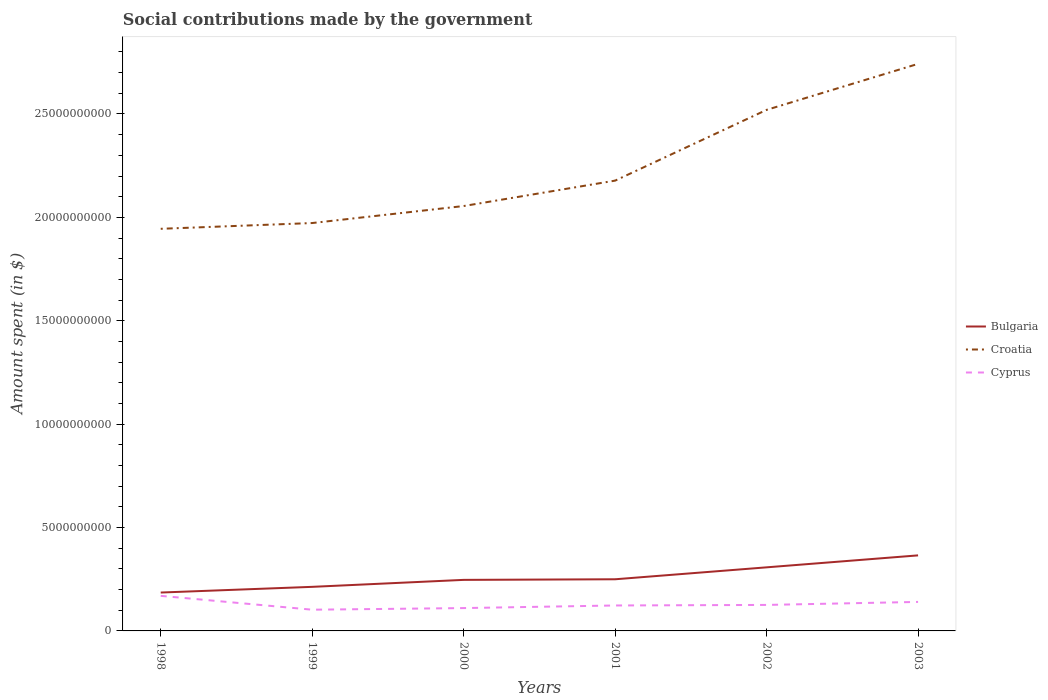How many different coloured lines are there?
Offer a very short reply. 3. Does the line corresponding to Bulgaria intersect with the line corresponding to Cyprus?
Your response must be concise. No. Across all years, what is the maximum amount spent on social contributions in Cyprus?
Offer a very short reply. 1.03e+09. What is the total amount spent on social contributions in Croatia in the graph?
Offer a very short reply. -3.42e+09. What is the difference between the highest and the second highest amount spent on social contributions in Croatia?
Give a very brief answer. 7.98e+09. What is the difference between the highest and the lowest amount spent on social contributions in Cyprus?
Your response must be concise. 2. What is the difference between two consecutive major ticks on the Y-axis?
Offer a terse response. 5.00e+09. Are the values on the major ticks of Y-axis written in scientific E-notation?
Provide a succinct answer. No. How many legend labels are there?
Provide a short and direct response. 3. What is the title of the graph?
Your response must be concise. Social contributions made by the government. Does "Uganda" appear as one of the legend labels in the graph?
Offer a terse response. No. What is the label or title of the X-axis?
Offer a terse response. Years. What is the label or title of the Y-axis?
Offer a very short reply. Amount spent (in $). What is the Amount spent (in $) of Bulgaria in 1998?
Offer a terse response. 1.86e+09. What is the Amount spent (in $) of Croatia in 1998?
Provide a succinct answer. 1.94e+1. What is the Amount spent (in $) in Cyprus in 1998?
Provide a succinct answer. 1.70e+09. What is the Amount spent (in $) in Bulgaria in 1999?
Offer a very short reply. 2.13e+09. What is the Amount spent (in $) of Croatia in 1999?
Give a very brief answer. 1.97e+1. What is the Amount spent (in $) in Cyprus in 1999?
Make the answer very short. 1.03e+09. What is the Amount spent (in $) in Bulgaria in 2000?
Your answer should be compact. 2.47e+09. What is the Amount spent (in $) in Croatia in 2000?
Offer a terse response. 2.05e+1. What is the Amount spent (in $) in Cyprus in 2000?
Your response must be concise. 1.10e+09. What is the Amount spent (in $) in Bulgaria in 2001?
Offer a very short reply. 2.50e+09. What is the Amount spent (in $) of Croatia in 2001?
Give a very brief answer. 2.18e+1. What is the Amount spent (in $) in Cyprus in 2001?
Make the answer very short. 1.23e+09. What is the Amount spent (in $) in Bulgaria in 2002?
Provide a short and direct response. 3.08e+09. What is the Amount spent (in $) in Croatia in 2002?
Give a very brief answer. 2.52e+1. What is the Amount spent (in $) in Cyprus in 2002?
Make the answer very short. 1.26e+09. What is the Amount spent (in $) of Bulgaria in 2003?
Your answer should be compact. 3.65e+09. What is the Amount spent (in $) of Croatia in 2003?
Make the answer very short. 2.74e+1. What is the Amount spent (in $) of Cyprus in 2003?
Ensure brevity in your answer.  1.40e+09. Across all years, what is the maximum Amount spent (in $) in Bulgaria?
Provide a succinct answer. 3.65e+09. Across all years, what is the maximum Amount spent (in $) of Croatia?
Offer a very short reply. 2.74e+1. Across all years, what is the maximum Amount spent (in $) in Cyprus?
Make the answer very short. 1.70e+09. Across all years, what is the minimum Amount spent (in $) in Bulgaria?
Keep it short and to the point. 1.86e+09. Across all years, what is the minimum Amount spent (in $) of Croatia?
Make the answer very short. 1.94e+1. Across all years, what is the minimum Amount spent (in $) of Cyprus?
Make the answer very short. 1.03e+09. What is the total Amount spent (in $) of Bulgaria in the graph?
Your response must be concise. 1.57e+1. What is the total Amount spent (in $) of Croatia in the graph?
Your answer should be very brief. 1.34e+11. What is the total Amount spent (in $) in Cyprus in the graph?
Your response must be concise. 7.72e+09. What is the difference between the Amount spent (in $) in Bulgaria in 1998 and that in 1999?
Your answer should be very brief. -2.75e+08. What is the difference between the Amount spent (in $) in Croatia in 1998 and that in 1999?
Offer a very short reply. -2.79e+08. What is the difference between the Amount spent (in $) in Cyprus in 1998 and that in 1999?
Give a very brief answer. 6.69e+08. What is the difference between the Amount spent (in $) of Bulgaria in 1998 and that in 2000?
Provide a succinct answer. -6.13e+08. What is the difference between the Amount spent (in $) of Croatia in 1998 and that in 2000?
Keep it short and to the point. -1.10e+09. What is the difference between the Amount spent (in $) of Cyprus in 1998 and that in 2000?
Offer a very short reply. 5.91e+08. What is the difference between the Amount spent (in $) of Bulgaria in 1998 and that in 2001?
Your response must be concise. -6.42e+08. What is the difference between the Amount spent (in $) in Croatia in 1998 and that in 2001?
Make the answer very short. -2.33e+09. What is the difference between the Amount spent (in $) of Cyprus in 1998 and that in 2001?
Your answer should be very brief. 4.65e+08. What is the difference between the Amount spent (in $) in Bulgaria in 1998 and that in 2002?
Your response must be concise. -1.22e+09. What is the difference between the Amount spent (in $) in Croatia in 1998 and that in 2002?
Make the answer very short. -5.75e+09. What is the difference between the Amount spent (in $) in Cyprus in 1998 and that in 2002?
Give a very brief answer. 4.38e+08. What is the difference between the Amount spent (in $) in Bulgaria in 1998 and that in 2003?
Make the answer very short. -1.80e+09. What is the difference between the Amount spent (in $) in Croatia in 1998 and that in 2003?
Make the answer very short. -7.98e+09. What is the difference between the Amount spent (in $) of Cyprus in 1998 and that in 2003?
Ensure brevity in your answer.  2.93e+08. What is the difference between the Amount spent (in $) in Bulgaria in 1999 and that in 2000?
Keep it short and to the point. -3.37e+08. What is the difference between the Amount spent (in $) in Croatia in 1999 and that in 2000?
Keep it short and to the point. -8.22e+08. What is the difference between the Amount spent (in $) in Cyprus in 1999 and that in 2000?
Your response must be concise. -7.84e+07. What is the difference between the Amount spent (in $) of Bulgaria in 1999 and that in 2001?
Provide a short and direct response. -3.66e+08. What is the difference between the Amount spent (in $) in Croatia in 1999 and that in 2001?
Give a very brief answer. -2.05e+09. What is the difference between the Amount spent (in $) in Cyprus in 1999 and that in 2001?
Give a very brief answer. -2.04e+08. What is the difference between the Amount spent (in $) in Bulgaria in 1999 and that in 2002?
Provide a succinct answer. -9.43e+08. What is the difference between the Amount spent (in $) of Croatia in 1999 and that in 2002?
Ensure brevity in your answer.  -5.47e+09. What is the difference between the Amount spent (in $) in Cyprus in 1999 and that in 2002?
Provide a short and direct response. -2.31e+08. What is the difference between the Amount spent (in $) of Bulgaria in 1999 and that in 2003?
Offer a terse response. -1.52e+09. What is the difference between the Amount spent (in $) of Croatia in 1999 and that in 2003?
Your response must be concise. -7.70e+09. What is the difference between the Amount spent (in $) of Cyprus in 1999 and that in 2003?
Your answer should be compact. -3.77e+08. What is the difference between the Amount spent (in $) in Bulgaria in 2000 and that in 2001?
Ensure brevity in your answer.  -2.89e+07. What is the difference between the Amount spent (in $) in Croatia in 2000 and that in 2001?
Make the answer very short. -1.23e+09. What is the difference between the Amount spent (in $) in Cyprus in 2000 and that in 2001?
Your answer should be compact. -1.26e+08. What is the difference between the Amount spent (in $) of Bulgaria in 2000 and that in 2002?
Your answer should be very brief. -6.06e+08. What is the difference between the Amount spent (in $) of Croatia in 2000 and that in 2002?
Make the answer very short. -4.65e+09. What is the difference between the Amount spent (in $) of Cyprus in 2000 and that in 2002?
Provide a succinct answer. -1.53e+08. What is the difference between the Amount spent (in $) of Bulgaria in 2000 and that in 2003?
Provide a succinct answer. -1.18e+09. What is the difference between the Amount spent (in $) in Croatia in 2000 and that in 2003?
Offer a terse response. -6.88e+09. What is the difference between the Amount spent (in $) of Cyprus in 2000 and that in 2003?
Make the answer very short. -2.98e+08. What is the difference between the Amount spent (in $) in Bulgaria in 2001 and that in 2002?
Your response must be concise. -5.77e+08. What is the difference between the Amount spent (in $) of Croatia in 2001 and that in 2002?
Keep it short and to the point. -3.42e+09. What is the difference between the Amount spent (in $) of Cyprus in 2001 and that in 2002?
Provide a succinct answer. -2.68e+07. What is the difference between the Amount spent (in $) in Bulgaria in 2001 and that in 2003?
Offer a very short reply. -1.16e+09. What is the difference between the Amount spent (in $) in Croatia in 2001 and that in 2003?
Ensure brevity in your answer.  -5.65e+09. What is the difference between the Amount spent (in $) in Cyprus in 2001 and that in 2003?
Ensure brevity in your answer.  -1.72e+08. What is the difference between the Amount spent (in $) of Bulgaria in 2002 and that in 2003?
Your answer should be very brief. -5.78e+08. What is the difference between the Amount spent (in $) in Croatia in 2002 and that in 2003?
Ensure brevity in your answer.  -2.22e+09. What is the difference between the Amount spent (in $) in Cyprus in 2002 and that in 2003?
Make the answer very short. -1.46e+08. What is the difference between the Amount spent (in $) in Bulgaria in 1998 and the Amount spent (in $) in Croatia in 1999?
Ensure brevity in your answer.  -1.79e+1. What is the difference between the Amount spent (in $) in Bulgaria in 1998 and the Amount spent (in $) in Cyprus in 1999?
Offer a very short reply. 8.30e+08. What is the difference between the Amount spent (in $) of Croatia in 1998 and the Amount spent (in $) of Cyprus in 1999?
Give a very brief answer. 1.84e+1. What is the difference between the Amount spent (in $) of Bulgaria in 1998 and the Amount spent (in $) of Croatia in 2000?
Your answer should be compact. -1.87e+1. What is the difference between the Amount spent (in $) in Bulgaria in 1998 and the Amount spent (in $) in Cyprus in 2000?
Keep it short and to the point. 7.52e+08. What is the difference between the Amount spent (in $) of Croatia in 1998 and the Amount spent (in $) of Cyprus in 2000?
Your answer should be compact. 1.83e+1. What is the difference between the Amount spent (in $) in Bulgaria in 1998 and the Amount spent (in $) in Croatia in 2001?
Give a very brief answer. -1.99e+1. What is the difference between the Amount spent (in $) of Bulgaria in 1998 and the Amount spent (in $) of Cyprus in 2001?
Your answer should be very brief. 6.26e+08. What is the difference between the Amount spent (in $) in Croatia in 1998 and the Amount spent (in $) in Cyprus in 2001?
Ensure brevity in your answer.  1.82e+1. What is the difference between the Amount spent (in $) in Bulgaria in 1998 and the Amount spent (in $) in Croatia in 2002?
Your answer should be very brief. -2.33e+1. What is the difference between the Amount spent (in $) of Bulgaria in 1998 and the Amount spent (in $) of Cyprus in 2002?
Ensure brevity in your answer.  5.99e+08. What is the difference between the Amount spent (in $) in Croatia in 1998 and the Amount spent (in $) in Cyprus in 2002?
Provide a succinct answer. 1.82e+1. What is the difference between the Amount spent (in $) in Bulgaria in 1998 and the Amount spent (in $) in Croatia in 2003?
Offer a very short reply. -2.56e+1. What is the difference between the Amount spent (in $) of Bulgaria in 1998 and the Amount spent (in $) of Cyprus in 2003?
Make the answer very short. 4.53e+08. What is the difference between the Amount spent (in $) of Croatia in 1998 and the Amount spent (in $) of Cyprus in 2003?
Give a very brief answer. 1.80e+1. What is the difference between the Amount spent (in $) of Bulgaria in 1999 and the Amount spent (in $) of Croatia in 2000?
Ensure brevity in your answer.  -1.84e+1. What is the difference between the Amount spent (in $) in Bulgaria in 1999 and the Amount spent (in $) in Cyprus in 2000?
Your answer should be compact. 1.03e+09. What is the difference between the Amount spent (in $) in Croatia in 1999 and the Amount spent (in $) in Cyprus in 2000?
Your response must be concise. 1.86e+1. What is the difference between the Amount spent (in $) of Bulgaria in 1999 and the Amount spent (in $) of Croatia in 2001?
Make the answer very short. -1.96e+1. What is the difference between the Amount spent (in $) of Bulgaria in 1999 and the Amount spent (in $) of Cyprus in 2001?
Provide a succinct answer. 9.01e+08. What is the difference between the Amount spent (in $) in Croatia in 1999 and the Amount spent (in $) in Cyprus in 2001?
Your answer should be compact. 1.85e+1. What is the difference between the Amount spent (in $) in Bulgaria in 1999 and the Amount spent (in $) in Croatia in 2002?
Ensure brevity in your answer.  -2.31e+1. What is the difference between the Amount spent (in $) in Bulgaria in 1999 and the Amount spent (in $) in Cyprus in 2002?
Make the answer very short. 8.74e+08. What is the difference between the Amount spent (in $) in Croatia in 1999 and the Amount spent (in $) in Cyprus in 2002?
Your response must be concise. 1.85e+1. What is the difference between the Amount spent (in $) in Bulgaria in 1999 and the Amount spent (in $) in Croatia in 2003?
Your answer should be very brief. -2.53e+1. What is the difference between the Amount spent (in $) in Bulgaria in 1999 and the Amount spent (in $) in Cyprus in 2003?
Make the answer very short. 7.29e+08. What is the difference between the Amount spent (in $) of Croatia in 1999 and the Amount spent (in $) of Cyprus in 2003?
Offer a very short reply. 1.83e+1. What is the difference between the Amount spent (in $) of Bulgaria in 2000 and the Amount spent (in $) of Croatia in 2001?
Your answer should be very brief. -1.93e+1. What is the difference between the Amount spent (in $) of Bulgaria in 2000 and the Amount spent (in $) of Cyprus in 2001?
Your answer should be compact. 1.24e+09. What is the difference between the Amount spent (in $) of Croatia in 2000 and the Amount spent (in $) of Cyprus in 2001?
Your answer should be very brief. 1.93e+1. What is the difference between the Amount spent (in $) in Bulgaria in 2000 and the Amount spent (in $) in Croatia in 2002?
Offer a terse response. -2.27e+1. What is the difference between the Amount spent (in $) of Bulgaria in 2000 and the Amount spent (in $) of Cyprus in 2002?
Offer a terse response. 1.21e+09. What is the difference between the Amount spent (in $) of Croatia in 2000 and the Amount spent (in $) of Cyprus in 2002?
Make the answer very short. 1.93e+1. What is the difference between the Amount spent (in $) of Bulgaria in 2000 and the Amount spent (in $) of Croatia in 2003?
Provide a short and direct response. -2.50e+1. What is the difference between the Amount spent (in $) of Bulgaria in 2000 and the Amount spent (in $) of Cyprus in 2003?
Your answer should be compact. 1.07e+09. What is the difference between the Amount spent (in $) in Croatia in 2000 and the Amount spent (in $) in Cyprus in 2003?
Make the answer very short. 1.91e+1. What is the difference between the Amount spent (in $) of Bulgaria in 2001 and the Amount spent (in $) of Croatia in 2002?
Offer a very short reply. -2.27e+1. What is the difference between the Amount spent (in $) of Bulgaria in 2001 and the Amount spent (in $) of Cyprus in 2002?
Ensure brevity in your answer.  1.24e+09. What is the difference between the Amount spent (in $) in Croatia in 2001 and the Amount spent (in $) in Cyprus in 2002?
Offer a very short reply. 2.05e+1. What is the difference between the Amount spent (in $) of Bulgaria in 2001 and the Amount spent (in $) of Croatia in 2003?
Provide a succinct answer. -2.49e+1. What is the difference between the Amount spent (in $) of Bulgaria in 2001 and the Amount spent (in $) of Cyprus in 2003?
Your response must be concise. 1.09e+09. What is the difference between the Amount spent (in $) of Croatia in 2001 and the Amount spent (in $) of Cyprus in 2003?
Your answer should be compact. 2.04e+1. What is the difference between the Amount spent (in $) in Bulgaria in 2002 and the Amount spent (in $) in Croatia in 2003?
Your answer should be compact. -2.43e+1. What is the difference between the Amount spent (in $) of Bulgaria in 2002 and the Amount spent (in $) of Cyprus in 2003?
Provide a short and direct response. 1.67e+09. What is the difference between the Amount spent (in $) in Croatia in 2002 and the Amount spent (in $) in Cyprus in 2003?
Provide a short and direct response. 2.38e+1. What is the average Amount spent (in $) of Bulgaria per year?
Offer a very short reply. 2.61e+09. What is the average Amount spent (in $) of Croatia per year?
Offer a terse response. 2.24e+1. What is the average Amount spent (in $) of Cyprus per year?
Your answer should be very brief. 1.29e+09. In the year 1998, what is the difference between the Amount spent (in $) of Bulgaria and Amount spent (in $) of Croatia?
Offer a very short reply. -1.76e+1. In the year 1998, what is the difference between the Amount spent (in $) in Bulgaria and Amount spent (in $) in Cyprus?
Offer a very short reply. 1.61e+08. In the year 1998, what is the difference between the Amount spent (in $) in Croatia and Amount spent (in $) in Cyprus?
Provide a short and direct response. 1.78e+1. In the year 1999, what is the difference between the Amount spent (in $) in Bulgaria and Amount spent (in $) in Croatia?
Give a very brief answer. -1.76e+1. In the year 1999, what is the difference between the Amount spent (in $) of Bulgaria and Amount spent (in $) of Cyprus?
Provide a succinct answer. 1.11e+09. In the year 1999, what is the difference between the Amount spent (in $) of Croatia and Amount spent (in $) of Cyprus?
Your answer should be very brief. 1.87e+1. In the year 2000, what is the difference between the Amount spent (in $) of Bulgaria and Amount spent (in $) of Croatia?
Your answer should be compact. -1.81e+1. In the year 2000, what is the difference between the Amount spent (in $) in Bulgaria and Amount spent (in $) in Cyprus?
Give a very brief answer. 1.36e+09. In the year 2000, what is the difference between the Amount spent (in $) in Croatia and Amount spent (in $) in Cyprus?
Provide a short and direct response. 1.94e+1. In the year 2001, what is the difference between the Amount spent (in $) in Bulgaria and Amount spent (in $) in Croatia?
Provide a short and direct response. -1.93e+1. In the year 2001, what is the difference between the Amount spent (in $) of Bulgaria and Amount spent (in $) of Cyprus?
Your answer should be very brief. 1.27e+09. In the year 2001, what is the difference between the Amount spent (in $) in Croatia and Amount spent (in $) in Cyprus?
Your answer should be very brief. 2.05e+1. In the year 2002, what is the difference between the Amount spent (in $) of Bulgaria and Amount spent (in $) of Croatia?
Offer a terse response. -2.21e+1. In the year 2002, what is the difference between the Amount spent (in $) of Bulgaria and Amount spent (in $) of Cyprus?
Provide a short and direct response. 1.82e+09. In the year 2002, what is the difference between the Amount spent (in $) in Croatia and Amount spent (in $) in Cyprus?
Give a very brief answer. 2.39e+1. In the year 2003, what is the difference between the Amount spent (in $) of Bulgaria and Amount spent (in $) of Croatia?
Offer a very short reply. -2.38e+1. In the year 2003, what is the difference between the Amount spent (in $) in Bulgaria and Amount spent (in $) in Cyprus?
Offer a very short reply. 2.25e+09. In the year 2003, what is the difference between the Amount spent (in $) of Croatia and Amount spent (in $) of Cyprus?
Your answer should be very brief. 2.60e+1. What is the ratio of the Amount spent (in $) in Bulgaria in 1998 to that in 1999?
Keep it short and to the point. 0.87. What is the ratio of the Amount spent (in $) in Croatia in 1998 to that in 1999?
Give a very brief answer. 0.99. What is the ratio of the Amount spent (in $) of Cyprus in 1998 to that in 1999?
Keep it short and to the point. 1.65. What is the ratio of the Amount spent (in $) in Bulgaria in 1998 to that in 2000?
Make the answer very short. 0.75. What is the ratio of the Amount spent (in $) of Croatia in 1998 to that in 2000?
Ensure brevity in your answer.  0.95. What is the ratio of the Amount spent (in $) of Cyprus in 1998 to that in 2000?
Keep it short and to the point. 1.53. What is the ratio of the Amount spent (in $) in Bulgaria in 1998 to that in 2001?
Offer a very short reply. 0.74. What is the ratio of the Amount spent (in $) in Croatia in 1998 to that in 2001?
Your response must be concise. 0.89. What is the ratio of the Amount spent (in $) of Cyprus in 1998 to that in 2001?
Provide a succinct answer. 1.38. What is the ratio of the Amount spent (in $) in Bulgaria in 1998 to that in 2002?
Your answer should be compact. 0.6. What is the ratio of the Amount spent (in $) in Croatia in 1998 to that in 2002?
Keep it short and to the point. 0.77. What is the ratio of the Amount spent (in $) in Cyprus in 1998 to that in 2002?
Your response must be concise. 1.35. What is the ratio of the Amount spent (in $) in Bulgaria in 1998 to that in 2003?
Offer a very short reply. 0.51. What is the ratio of the Amount spent (in $) of Croatia in 1998 to that in 2003?
Provide a short and direct response. 0.71. What is the ratio of the Amount spent (in $) of Cyprus in 1998 to that in 2003?
Offer a terse response. 1.21. What is the ratio of the Amount spent (in $) in Bulgaria in 1999 to that in 2000?
Keep it short and to the point. 0.86. What is the ratio of the Amount spent (in $) of Croatia in 1999 to that in 2000?
Give a very brief answer. 0.96. What is the ratio of the Amount spent (in $) of Cyprus in 1999 to that in 2000?
Offer a terse response. 0.93. What is the ratio of the Amount spent (in $) in Bulgaria in 1999 to that in 2001?
Offer a terse response. 0.85. What is the ratio of the Amount spent (in $) in Croatia in 1999 to that in 2001?
Keep it short and to the point. 0.91. What is the ratio of the Amount spent (in $) in Cyprus in 1999 to that in 2001?
Give a very brief answer. 0.83. What is the ratio of the Amount spent (in $) of Bulgaria in 1999 to that in 2002?
Your answer should be compact. 0.69. What is the ratio of the Amount spent (in $) of Croatia in 1999 to that in 2002?
Give a very brief answer. 0.78. What is the ratio of the Amount spent (in $) of Cyprus in 1999 to that in 2002?
Make the answer very short. 0.82. What is the ratio of the Amount spent (in $) in Bulgaria in 1999 to that in 2003?
Provide a succinct answer. 0.58. What is the ratio of the Amount spent (in $) of Croatia in 1999 to that in 2003?
Ensure brevity in your answer.  0.72. What is the ratio of the Amount spent (in $) in Cyprus in 1999 to that in 2003?
Your response must be concise. 0.73. What is the ratio of the Amount spent (in $) of Bulgaria in 2000 to that in 2001?
Make the answer very short. 0.99. What is the ratio of the Amount spent (in $) of Croatia in 2000 to that in 2001?
Your response must be concise. 0.94. What is the ratio of the Amount spent (in $) in Cyprus in 2000 to that in 2001?
Your answer should be compact. 0.9. What is the ratio of the Amount spent (in $) of Bulgaria in 2000 to that in 2002?
Your answer should be very brief. 0.8. What is the ratio of the Amount spent (in $) in Croatia in 2000 to that in 2002?
Offer a very short reply. 0.82. What is the ratio of the Amount spent (in $) in Cyprus in 2000 to that in 2002?
Offer a very short reply. 0.88. What is the ratio of the Amount spent (in $) of Bulgaria in 2000 to that in 2003?
Offer a very short reply. 0.68. What is the ratio of the Amount spent (in $) in Croatia in 2000 to that in 2003?
Provide a succinct answer. 0.75. What is the ratio of the Amount spent (in $) of Cyprus in 2000 to that in 2003?
Offer a very short reply. 0.79. What is the ratio of the Amount spent (in $) in Bulgaria in 2001 to that in 2002?
Offer a terse response. 0.81. What is the ratio of the Amount spent (in $) in Croatia in 2001 to that in 2002?
Provide a succinct answer. 0.86. What is the ratio of the Amount spent (in $) of Cyprus in 2001 to that in 2002?
Your answer should be very brief. 0.98. What is the ratio of the Amount spent (in $) of Bulgaria in 2001 to that in 2003?
Your answer should be compact. 0.68. What is the ratio of the Amount spent (in $) of Croatia in 2001 to that in 2003?
Keep it short and to the point. 0.79. What is the ratio of the Amount spent (in $) in Cyprus in 2001 to that in 2003?
Your answer should be compact. 0.88. What is the ratio of the Amount spent (in $) in Bulgaria in 2002 to that in 2003?
Ensure brevity in your answer.  0.84. What is the ratio of the Amount spent (in $) in Croatia in 2002 to that in 2003?
Your response must be concise. 0.92. What is the ratio of the Amount spent (in $) in Cyprus in 2002 to that in 2003?
Make the answer very short. 0.9. What is the difference between the highest and the second highest Amount spent (in $) of Bulgaria?
Provide a succinct answer. 5.78e+08. What is the difference between the highest and the second highest Amount spent (in $) in Croatia?
Your answer should be very brief. 2.22e+09. What is the difference between the highest and the second highest Amount spent (in $) in Cyprus?
Offer a very short reply. 2.93e+08. What is the difference between the highest and the lowest Amount spent (in $) in Bulgaria?
Your response must be concise. 1.80e+09. What is the difference between the highest and the lowest Amount spent (in $) of Croatia?
Your answer should be compact. 7.98e+09. What is the difference between the highest and the lowest Amount spent (in $) of Cyprus?
Provide a succinct answer. 6.69e+08. 